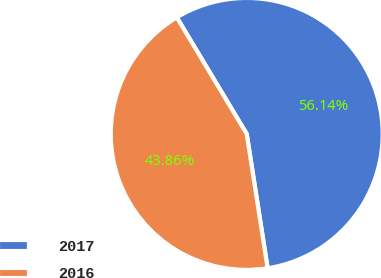Convert chart to OTSL. <chart><loc_0><loc_0><loc_500><loc_500><pie_chart><fcel>2017<fcel>2016<nl><fcel>56.14%<fcel>43.86%<nl></chart> 